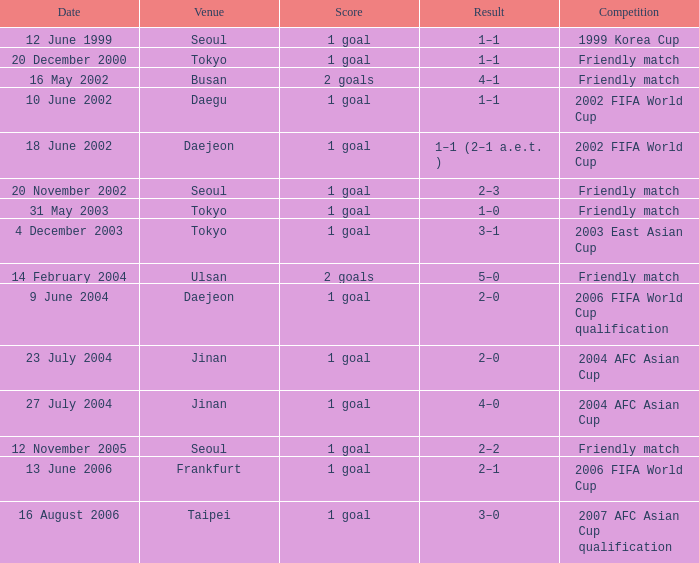What was the score of the game played on 16 August 2006? 1 goal. Give me the full table as a dictionary. {'header': ['Date', 'Venue', 'Score', 'Result', 'Competition'], 'rows': [['12 June 1999', 'Seoul', '1 goal', '1–1', '1999 Korea Cup'], ['20 December 2000', 'Tokyo', '1 goal', '1–1', 'Friendly match'], ['16 May 2002', 'Busan', '2 goals', '4–1', 'Friendly match'], ['10 June 2002', 'Daegu', '1 goal', '1–1', '2002 FIFA World Cup'], ['18 June 2002', 'Daejeon', '1 goal', '1–1 (2–1 a.e.t. )', '2002 FIFA World Cup'], ['20 November 2002', 'Seoul', '1 goal', '2–3', 'Friendly match'], ['31 May 2003', 'Tokyo', '1 goal', '1–0', 'Friendly match'], ['4 December 2003', 'Tokyo', '1 goal', '3–1', '2003 East Asian Cup'], ['14 February 2004', 'Ulsan', '2 goals', '5–0', 'Friendly match'], ['9 June 2004', 'Daejeon', '1 goal', '2–0', '2006 FIFA World Cup qualification'], ['23 July 2004', 'Jinan', '1 goal', '2–0', '2004 AFC Asian Cup'], ['27 July 2004', 'Jinan', '1 goal', '4–0', '2004 AFC Asian Cup'], ['12 November 2005', 'Seoul', '1 goal', '2–2', 'Friendly match'], ['13 June 2006', 'Frankfurt', '1 goal', '2–1', '2006 FIFA World Cup'], ['16 August 2006', 'Taipei', '1 goal', '3–0', '2007 AFC Asian Cup qualification']]} 